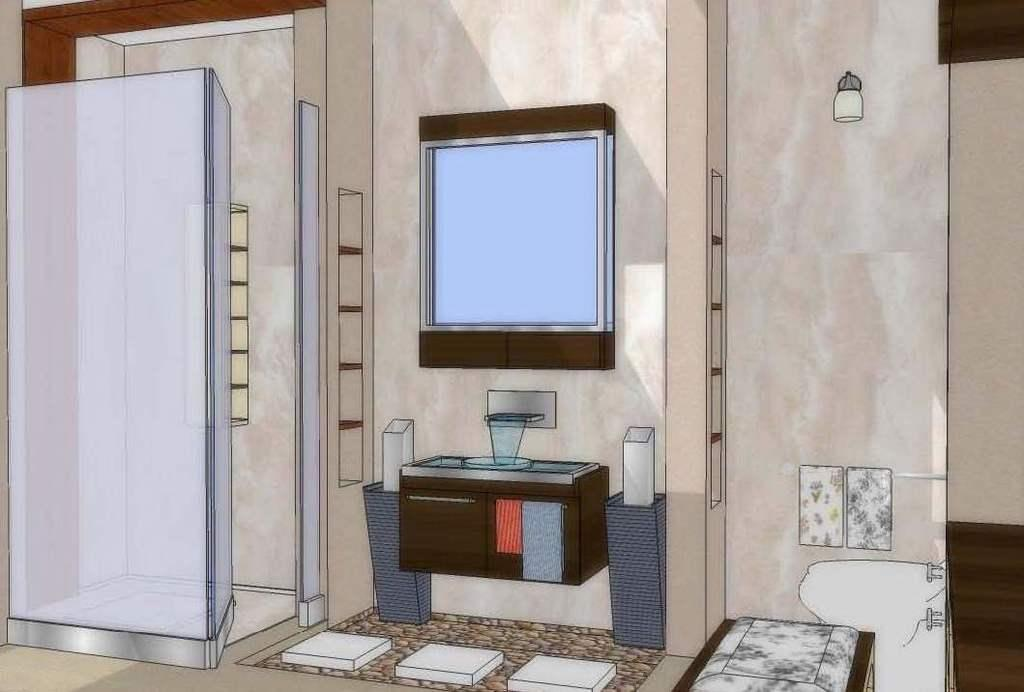What type of artwork is depicted in the image? The image appears to be a painting. What furniture piece can be seen in the painting? There is a TV table in the painting. Where is the TV located in the painting? The TV is on the wall in the painting. What object is used for washing in the painting? There is a basin in the painting. What source of illumination is present in the painting? There is a light in the painting. What architectural feature is visible in the painting? There is a wall in the painting. What type of brass instrument is being played in the painting? There is no brass instrument or any indication of music being played in the painting. 